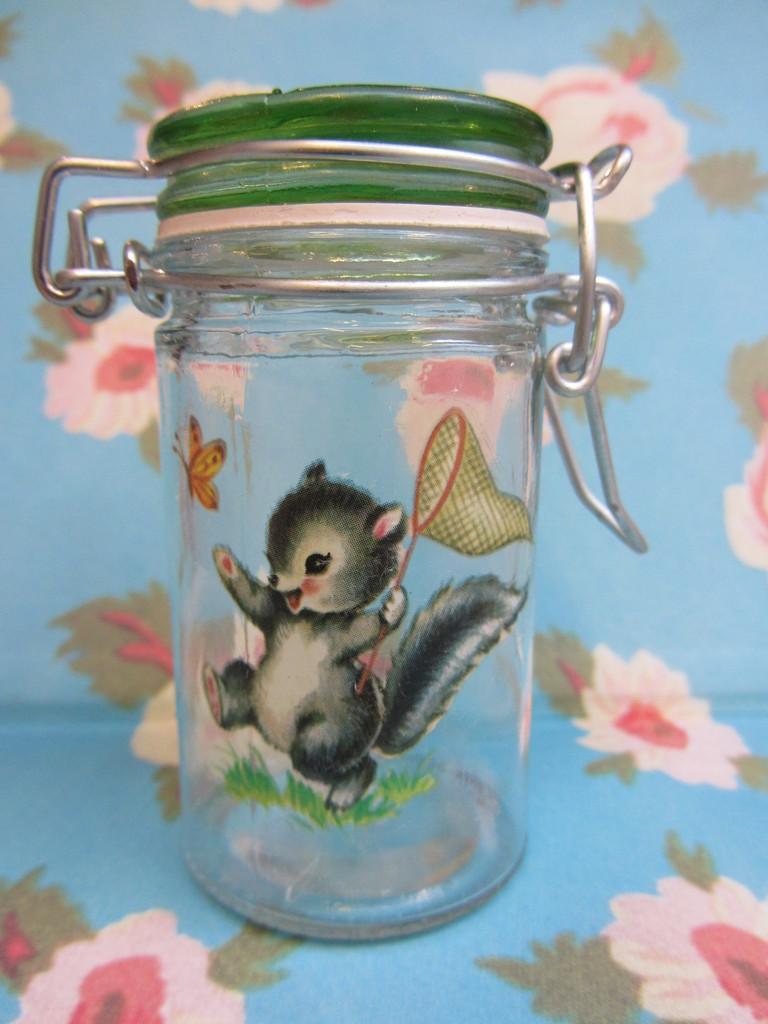Describe this image in one or two sentences. This is the picture of a jar to which there is a lid in green color and it is on the mat which is blue color. 